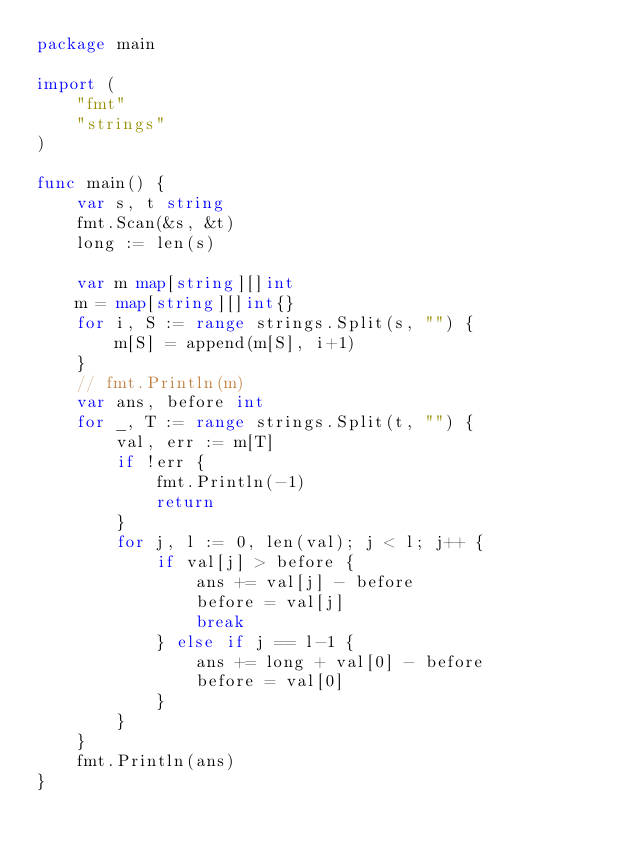Convert code to text. <code><loc_0><loc_0><loc_500><loc_500><_Go_>package main

import (
	"fmt"
	"strings"
)

func main() {
	var s, t string
	fmt.Scan(&s, &t)
	long := len(s)

	var m map[string][]int
	m = map[string][]int{}
	for i, S := range strings.Split(s, "") {
		m[S] = append(m[S], i+1)
	}
	// fmt.Println(m)
	var ans, before int
	for _, T := range strings.Split(t, "") {
		val, err := m[T]
		if !err {
			fmt.Println(-1)
			return
		}
		for j, l := 0, len(val); j < l; j++ {
			if val[j] > before {
				ans += val[j] - before
				before = val[j]
				break
			} else if j == l-1 {
				ans += long + val[0] - before
				before = val[0]
			}
		}
	}
	fmt.Println(ans)
}
</code> 